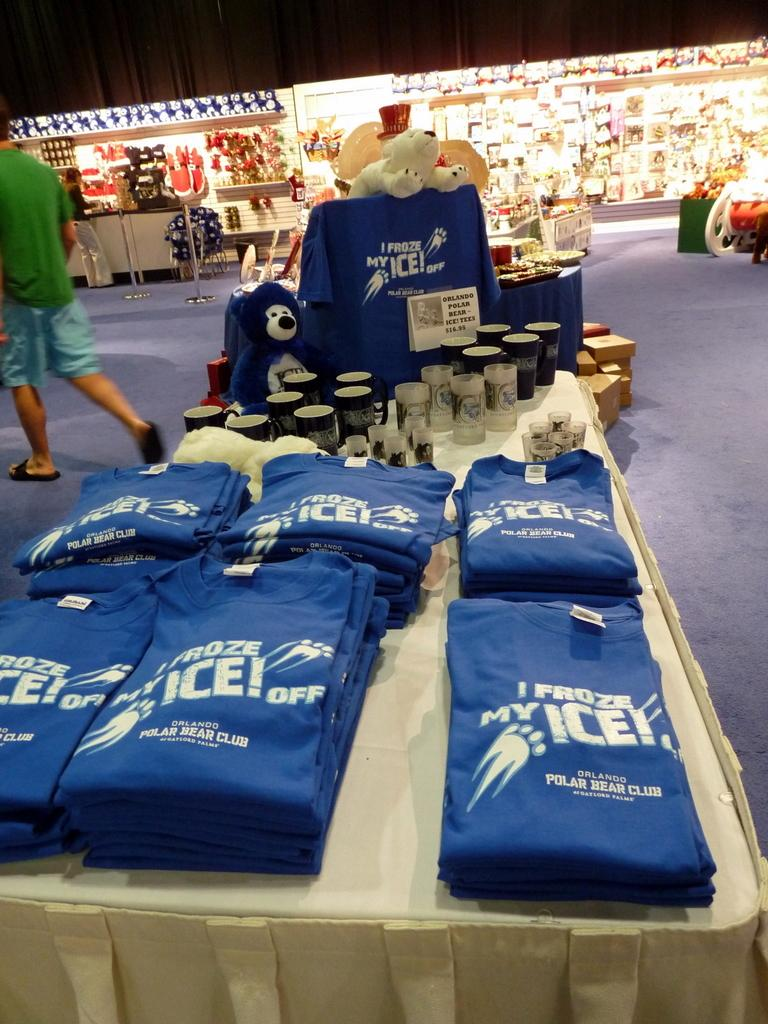<image>
Present a compact description of the photo's key features. table with various items for orlando polar bear club 